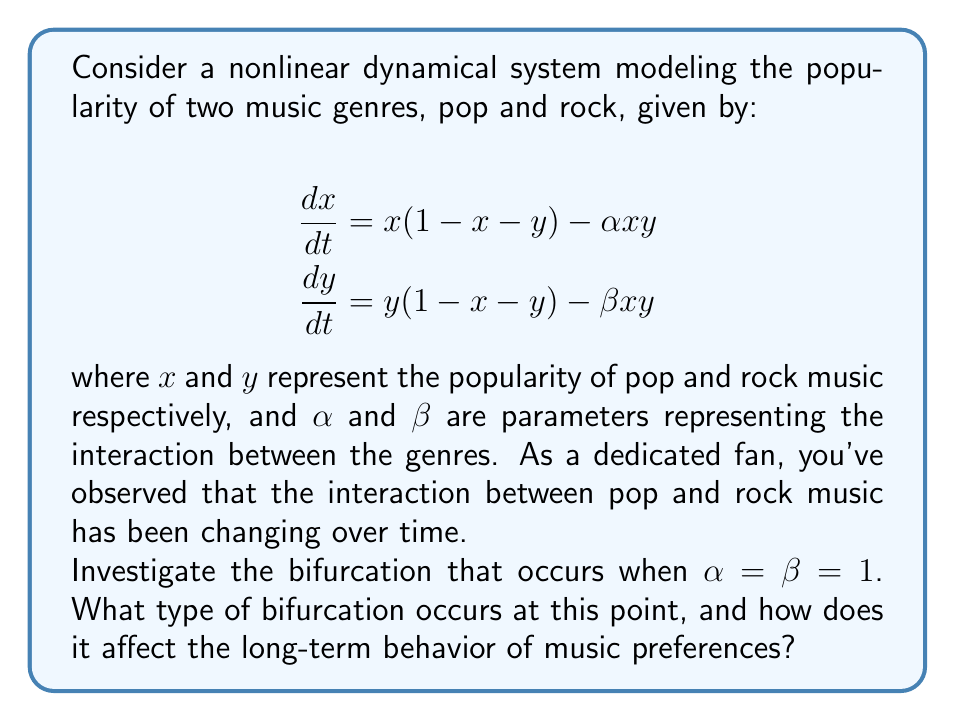Can you solve this math problem? To investigate the bifurcation, we'll follow these steps:

1) First, let's find the equilibrium points of the system by setting $\frac{dx}{dt} = \frac{dy}{dt} = 0$:

   $$\begin{align}
   x(1-x-y) - \alpha xy &= 0 \\
   y(1-x-y) - \beta xy &= 0
   \end{align}$$

2) When $\alpha = \beta = 1$, these equations simplify to:

   $$\begin{align}
   x(1-x-y) - xy &= 0 \\
   y(1-x-y) - xy &= 0
   \end{align}$$

3) Solving these equations, we find three equilibrium points:
   $(0,0)$, $(1,0)$, and $(0,1)$

4) To determine the stability of these points, we need to compute the Jacobian matrix:

   $$J = \begin{bmatrix}
   1-2x-y-\alpha y & -x-\alpha x \\
   -y-\beta y & 1-x-2y-\beta x
   \end{bmatrix}$$

5) Evaluating the Jacobian at $(0,0)$ when $\alpha = \beta = 1$:

   $$J_{(0,0)} = \begin{bmatrix}
   1 & 0 \\
   0 & 1
   \end{bmatrix}$$

   Both eigenvalues are positive, indicating an unstable node.

6) At $(1,0)$ and $(0,1)$:

   $$J_{(1,0)} = J_{(0,1)} = \begin{bmatrix}
   -1 & -1 \\
   -1 & -1
   \end{bmatrix}$$

   The eigenvalues are $0$ and $-2$, indicating a non-hyperbolic equilibrium.

7) The presence of a zero eigenvalue at $(1,0)$ and $(0,1)$ when $\alpha = \beta = 1$ indicates a bifurcation point.

8) As $\alpha$ and $\beta$ vary around 1, the stability of these equilibrium points changes. This is characteristic of a transcritical bifurcation.

9) In the context of music preferences, this bifurcation represents a critical point where the dominance of one genre over the other can shift dramatically with small changes in the interaction parameters.

10) Long-term behavior: Before the bifurcation, one genre dominates. After the bifurcation, both genres can coexist, or the system may exhibit more complex behavior, reflecting a more diverse music landscape.
Answer: Transcritical bifurcation at $\alpha = \beta = 1$, leading to potential coexistence of genres or more complex dynamics. 